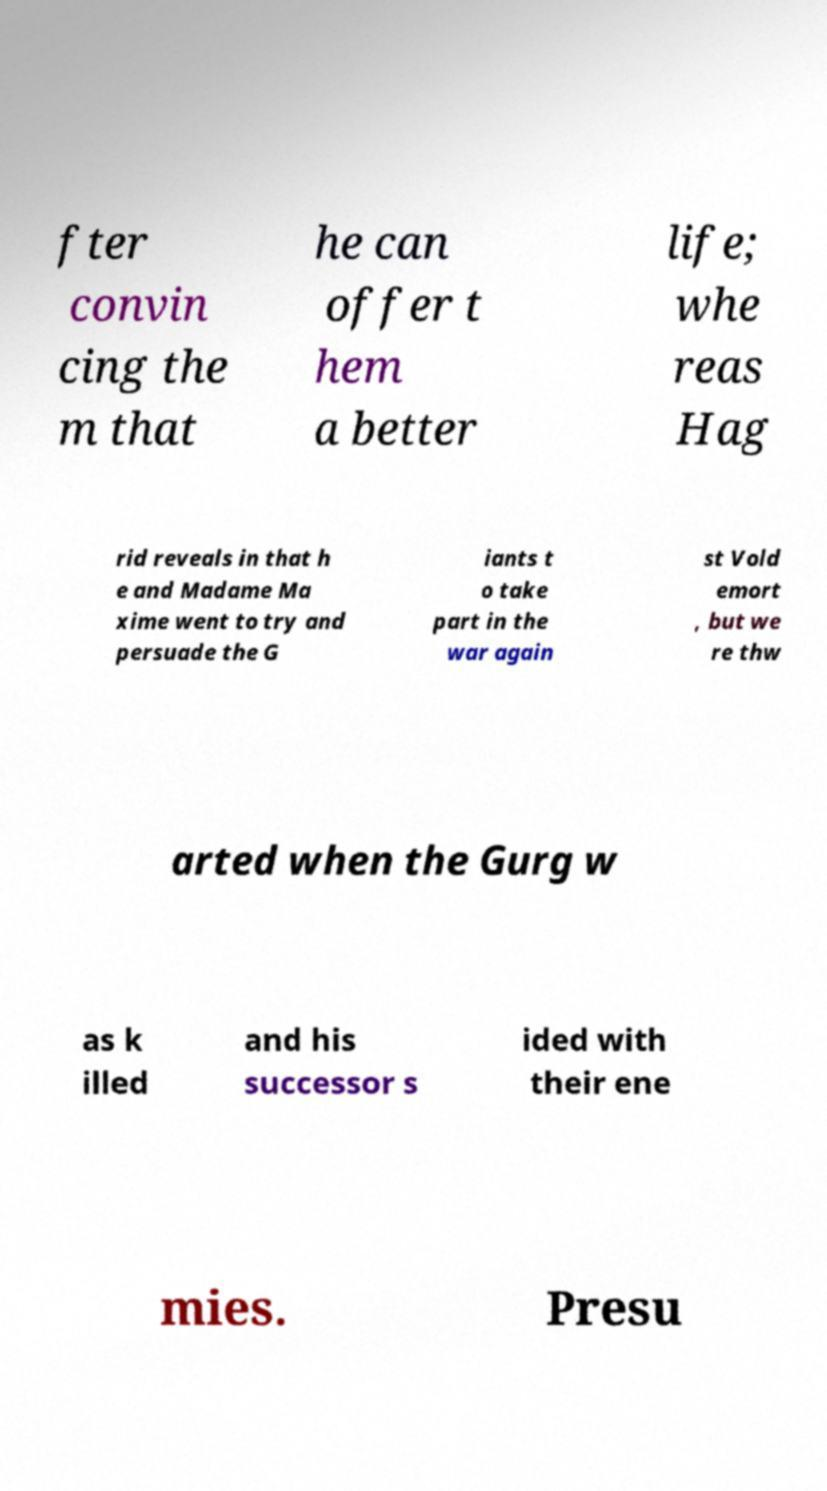Can you accurately transcribe the text from the provided image for me? fter convin cing the m that he can offer t hem a better life; whe reas Hag rid reveals in that h e and Madame Ma xime went to try and persuade the G iants t o take part in the war again st Vold emort , but we re thw arted when the Gurg w as k illed and his successor s ided with their ene mies. Presu 